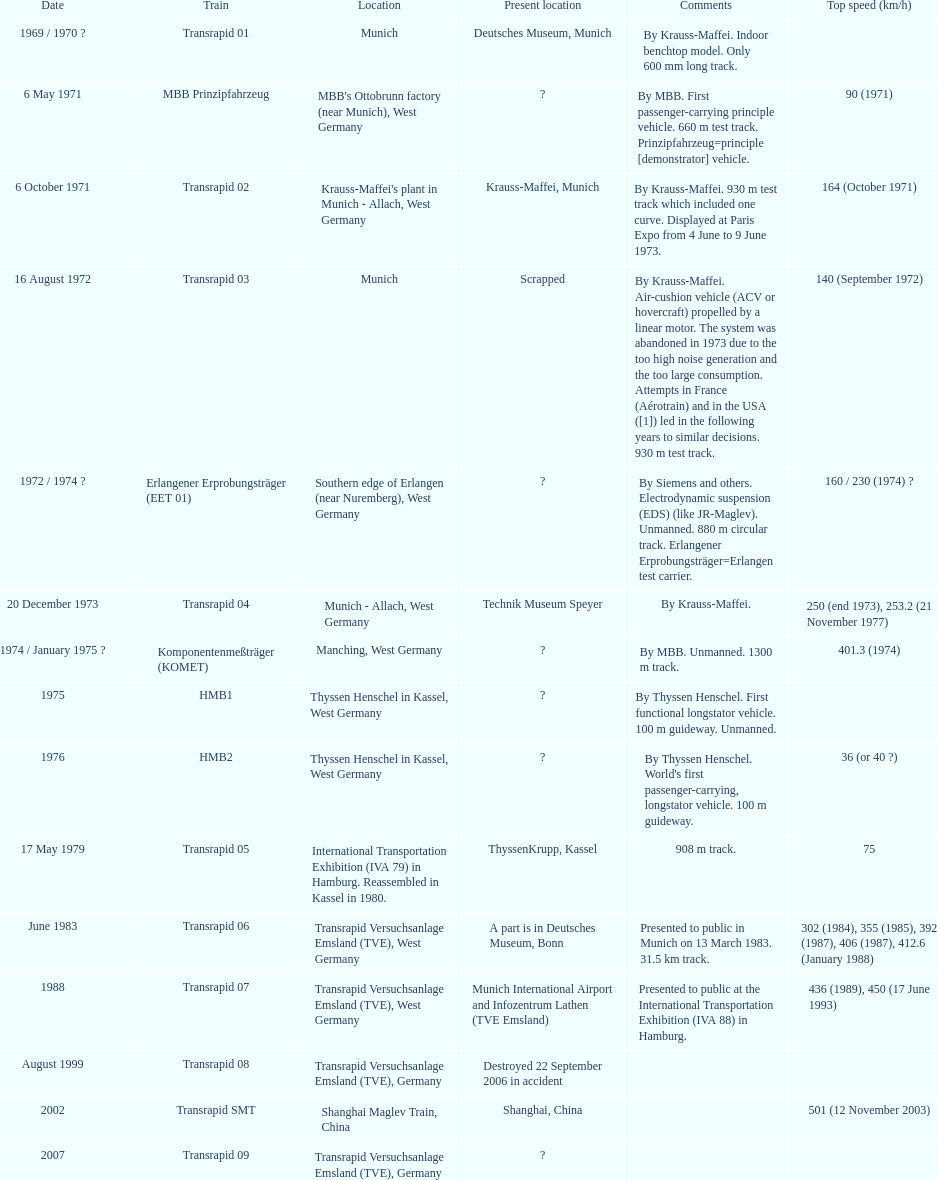What is the total of trains that were either dismantled or wrecked? 2. 